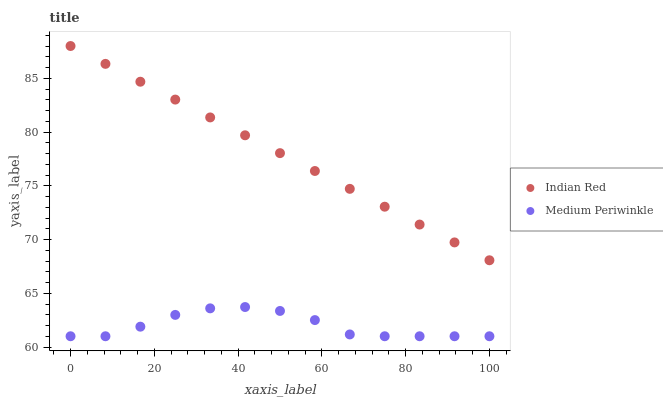Does Medium Periwinkle have the minimum area under the curve?
Answer yes or no. Yes. Does Indian Red have the maximum area under the curve?
Answer yes or no. Yes. Does Indian Red have the minimum area under the curve?
Answer yes or no. No. Is Indian Red the smoothest?
Answer yes or no. Yes. Is Medium Periwinkle the roughest?
Answer yes or no. Yes. Is Indian Red the roughest?
Answer yes or no. No. Does Medium Periwinkle have the lowest value?
Answer yes or no. Yes. Does Indian Red have the lowest value?
Answer yes or no. No. Does Indian Red have the highest value?
Answer yes or no. Yes. Is Medium Periwinkle less than Indian Red?
Answer yes or no. Yes. Is Indian Red greater than Medium Periwinkle?
Answer yes or no. Yes. Does Medium Periwinkle intersect Indian Red?
Answer yes or no. No. 